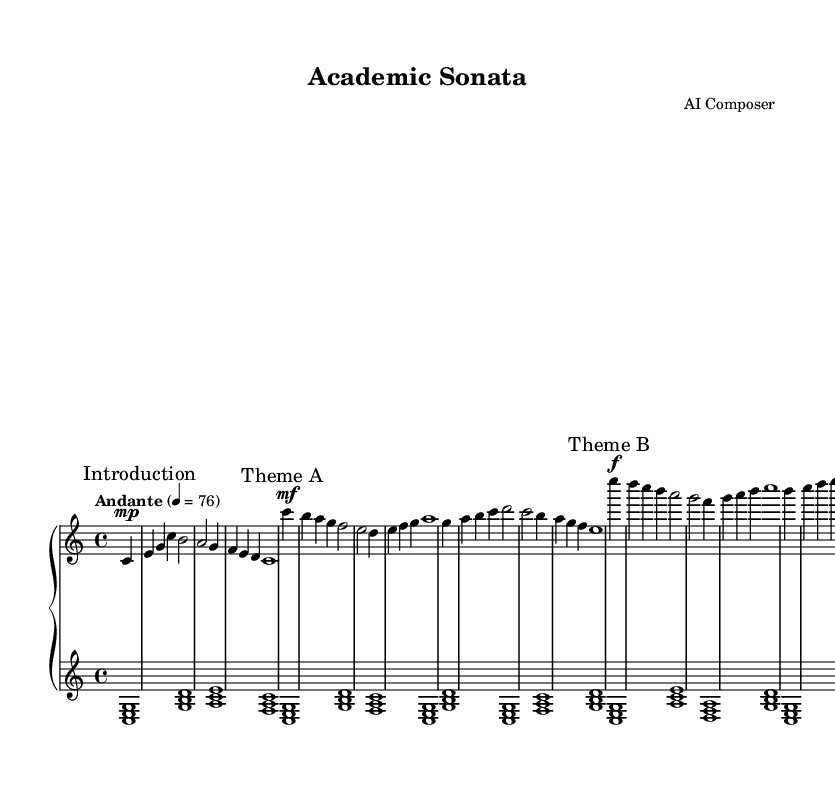What is the key signature of this music? The key signature is C major, which has no sharps or flats.
Answer: C major What is the time signature of the piece? The time signature indicates how many beats are in each measure; this piece has 4 beats per measure.
Answer: 4/4 What is the tempo marking given in the score? The tempo marking is indicated at the beginning and specifies the speed of the music; in this case, it is "Andante," which suggests a moderate walking pace.
Answer: Andante How many themes are present in the composition? The score clearly marks two themes, labeled as Theme A and Theme B, indicating their distinct musical sections.
Answer: Two Which dynamic marking is used at the beginning of Theme A? The dynamic marking denotes the level of loudness; at the beginning of Theme A, it is marked as "mf," indicating "mezzo-forte."
Answer: mf In which section is the introduction found? The introduction serves as the opening of the composition, and it is explicitly indicated before the themes, serving as a precursor to the thematic material.
Answer: Introduction What is the last note of Theme B? The last note of Theme B is found at the end of this section; analyzing the music reveals that it concludes with the note 'g.'
Answer: g 